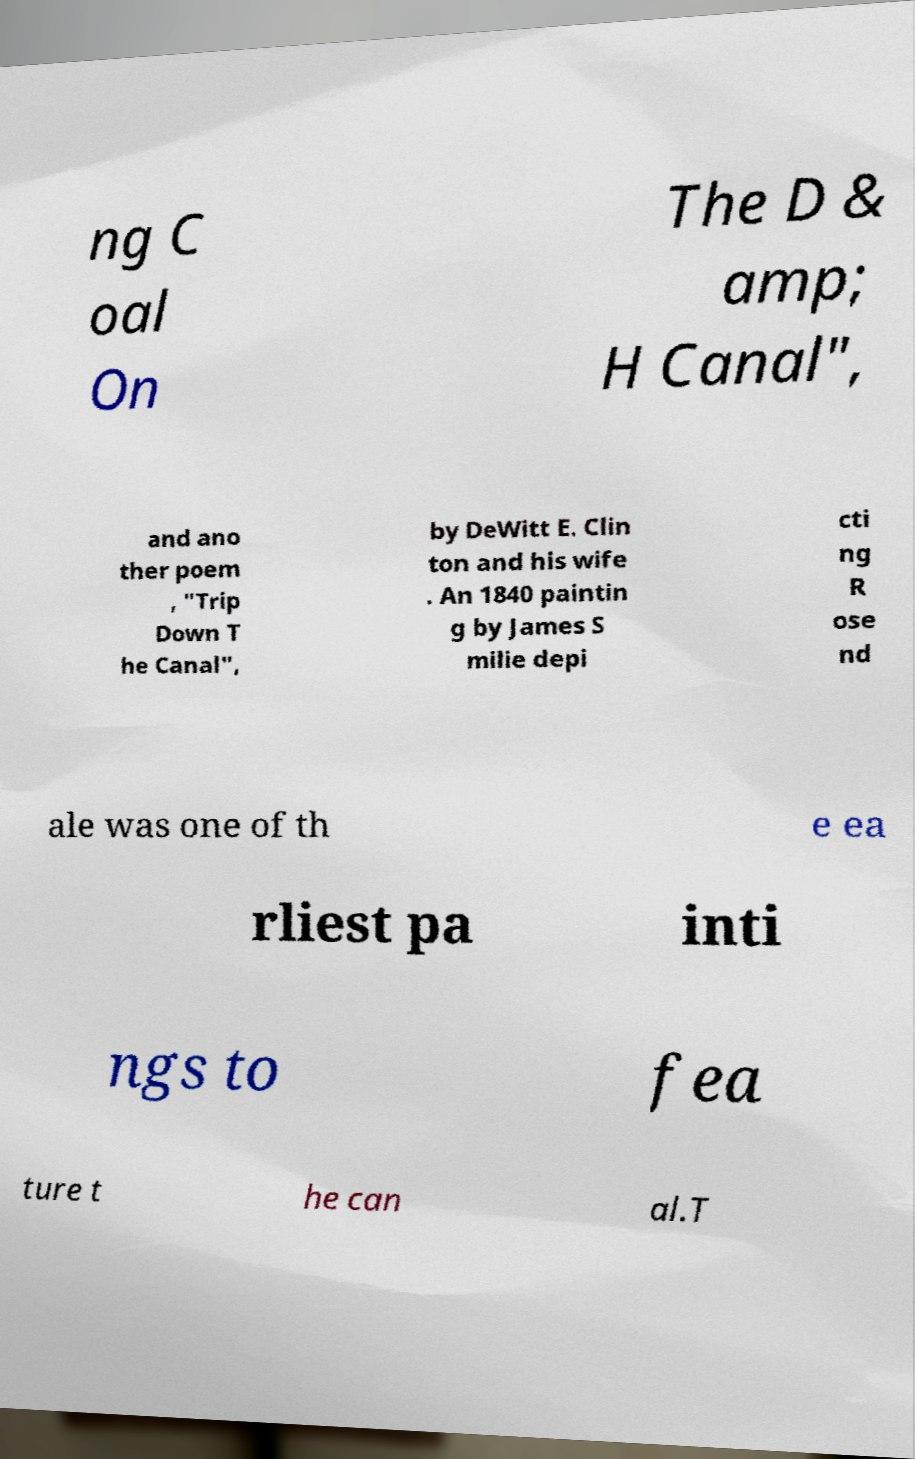What messages or text are displayed in this image? I need them in a readable, typed format. ng C oal On The D & amp; H Canal", and ano ther poem , "Trip Down T he Canal", by DeWitt E. Clin ton and his wife . An 1840 paintin g by James S milie depi cti ng R ose nd ale was one of th e ea rliest pa inti ngs to fea ture t he can al.T 